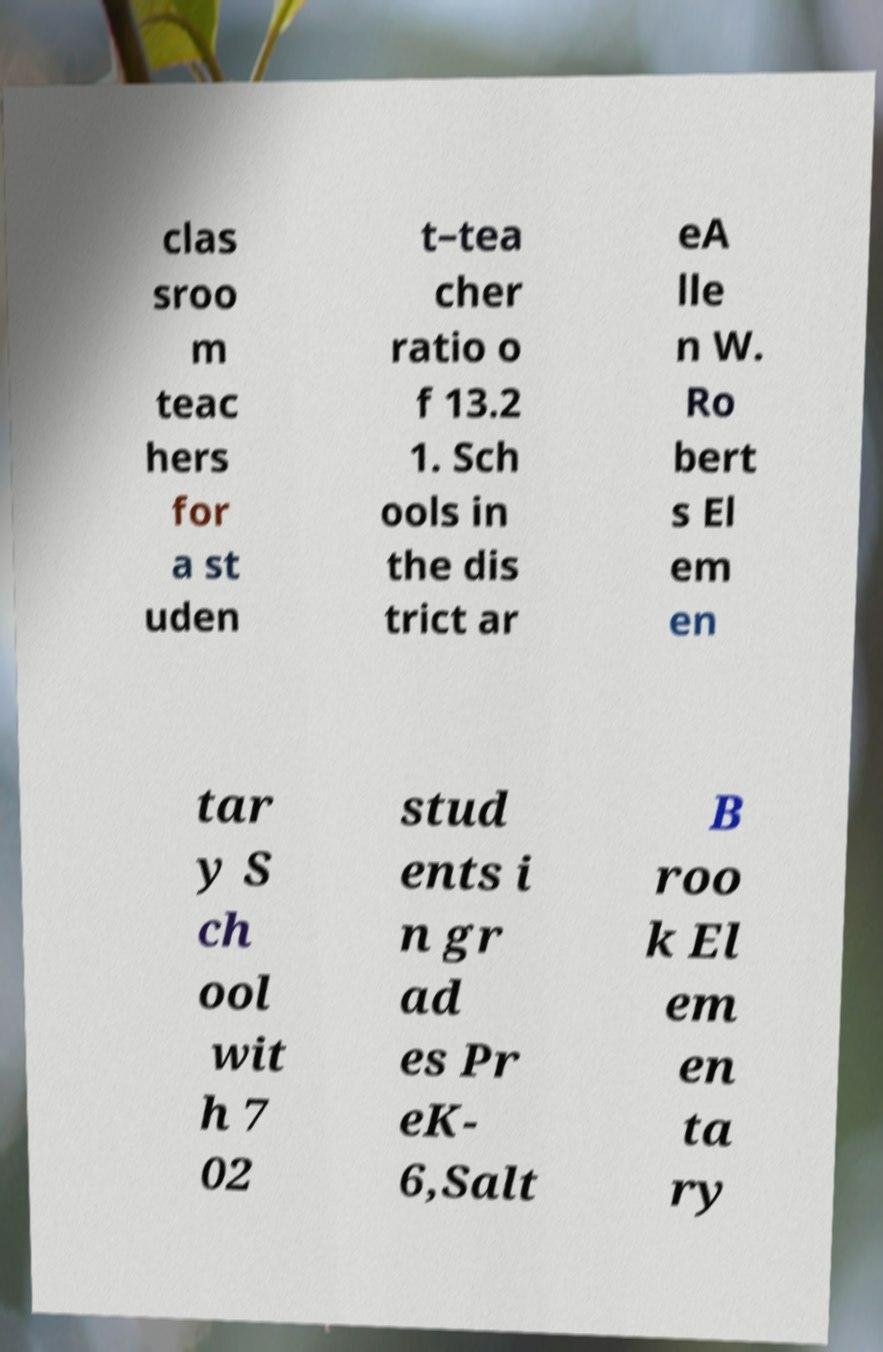Could you assist in decoding the text presented in this image and type it out clearly? clas sroo m teac hers for a st uden t–tea cher ratio o f 13.2 1. Sch ools in the dis trict ar eA lle n W. Ro bert s El em en tar y S ch ool wit h 7 02 stud ents i n gr ad es Pr eK- 6,Salt B roo k El em en ta ry 